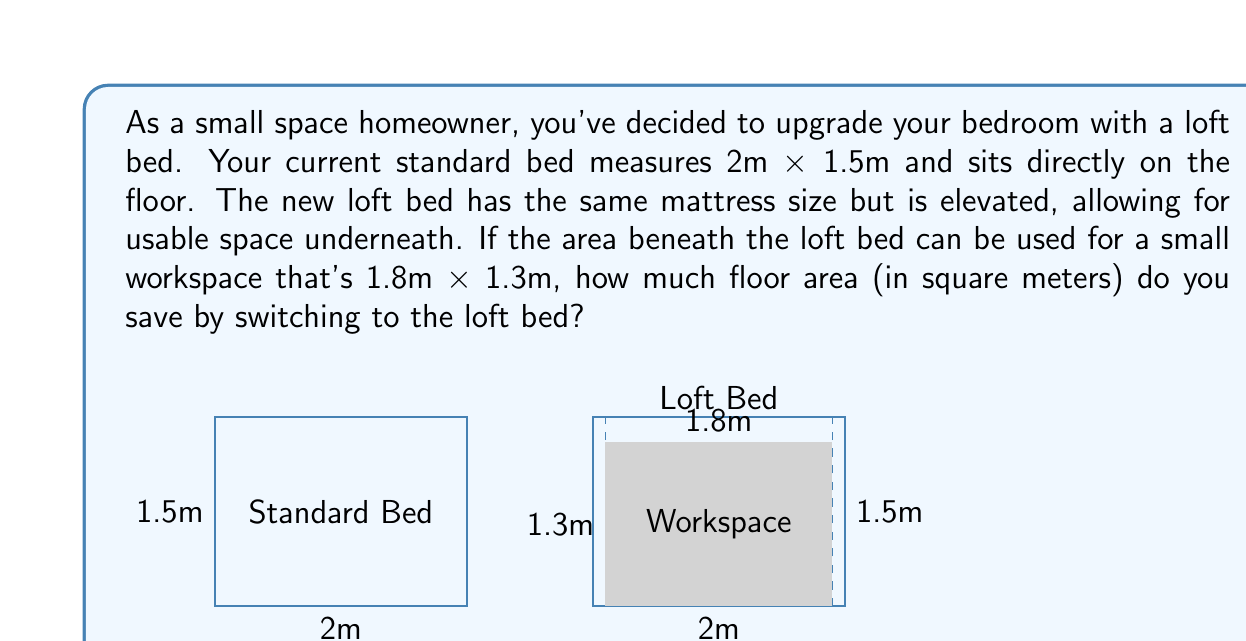Could you help me with this problem? Let's approach this step-by-step:

1) First, calculate the area occupied by the standard bed:
   $$A_{standard} = 2m \times 1.5m = 3m^2$$

2) Now, calculate the area of the workspace under the loft bed:
   $$A_{workspace} = 1.8m \times 1.3m = 2.34m^2$$

3) The loft bed still occupies the same floor space as the standard bed (3m²), but we can subtract the usable workspace area from this:
   $$A_{saved} = A_{standard} - A_{workspace}$$
   $$A_{saved} = 3m^2 - 2.34m^2 = 0.66m^2$$

Therefore, by switching to a loft bed, you save 0.66 square meters of floor space.
Answer: $0.66m^2$ 